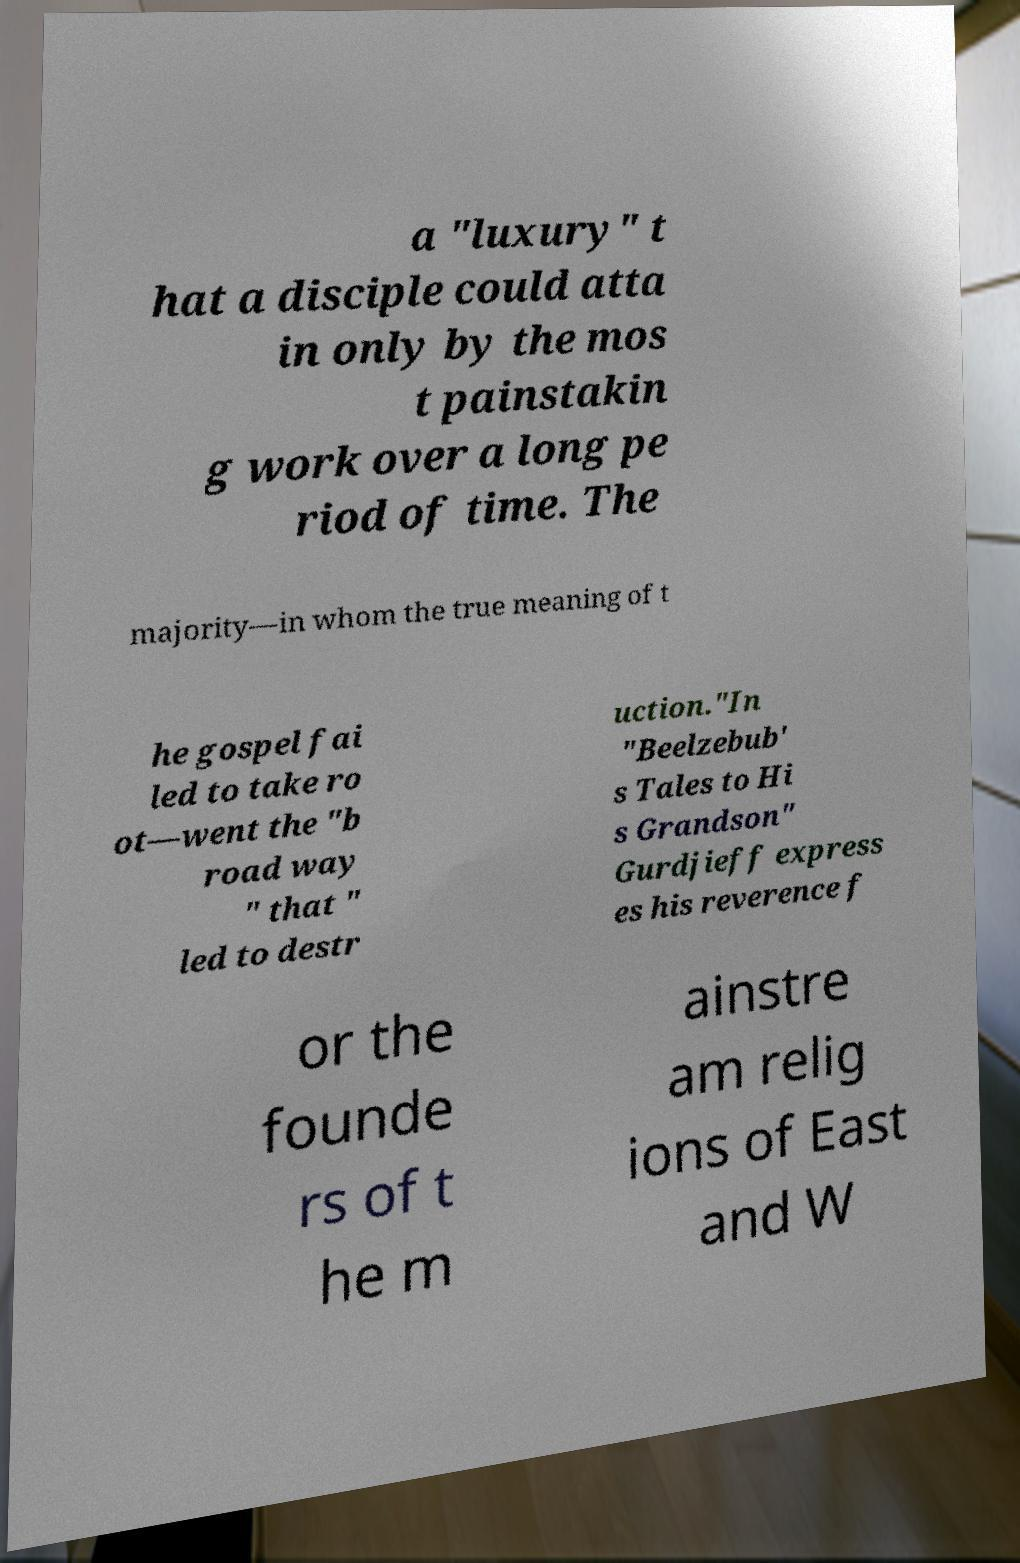Could you assist in decoding the text presented in this image and type it out clearly? a "luxury" t hat a disciple could atta in only by the mos t painstakin g work over a long pe riod of time. The majority—in whom the true meaning of t he gospel fai led to take ro ot—went the "b road way " that " led to destr uction."In "Beelzebub' s Tales to Hi s Grandson" Gurdjieff express es his reverence f or the founde rs of t he m ainstre am relig ions of East and W 